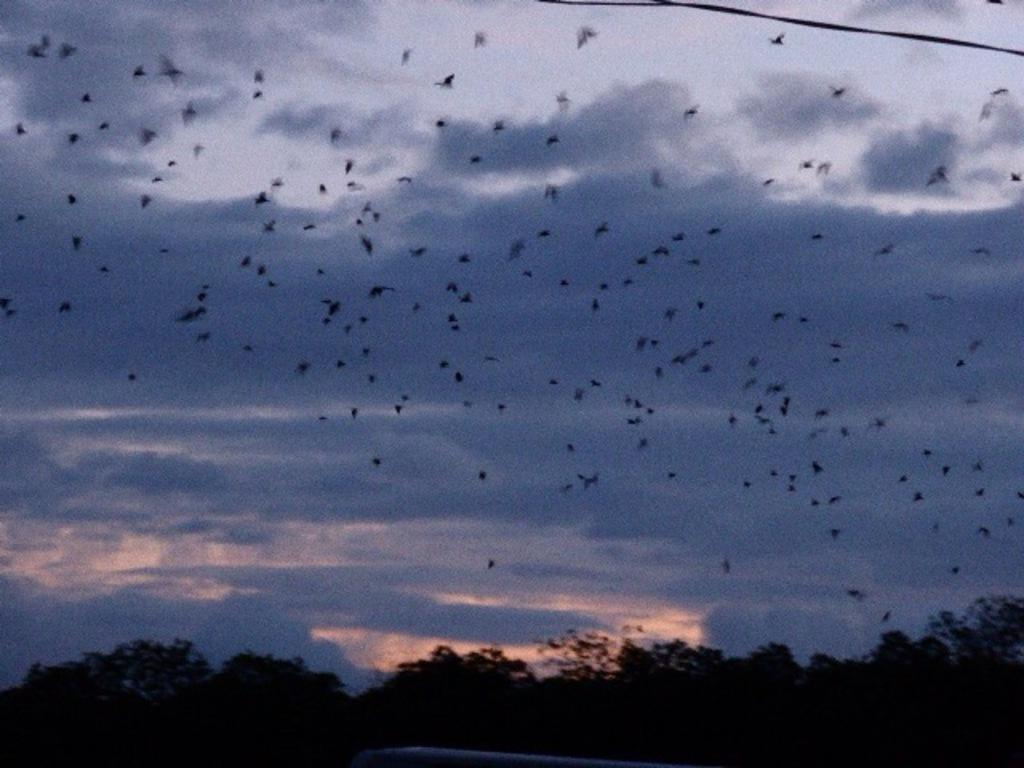What can be seen in the sky in the image? The sky with clouds is visible in the image. What animals are present in the image? There are birds in the image. What type of vegetation is in the image? There are trees in the image. What is the wire used for in the image? The purpose of the wire is not specified in the image. What is the object at the bottom of the image? There is an object at the bottom of the image, but its description is not provided in the facts. Can you describe the journey the monkey is taking in the image? There is no monkey present in the image, so it is not possible to describe a journey. 